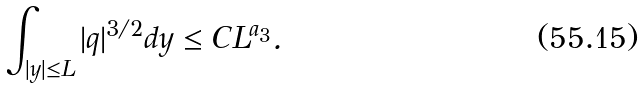<formula> <loc_0><loc_0><loc_500><loc_500>\int _ { | y | \leq L } | q | ^ { 3 / 2 } d y \leq C L ^ { a _ { 3 } } .</formula> 